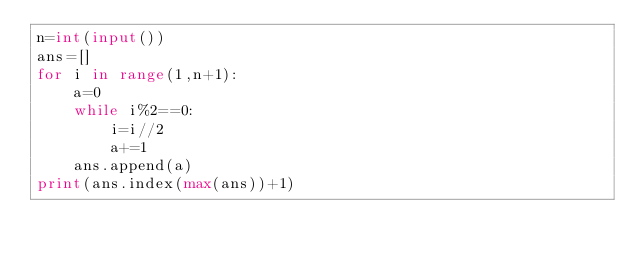<code> <loc_0><loc_0><loc_500><loc_500><_Python_>n=int(input())
ans=[]
for i in range(1,n+1):
    a=0
    while i%2==0:
        i=i//2
        a+=1
    ans.append(a)
print(ans.index(max(ans))+1)</code> 